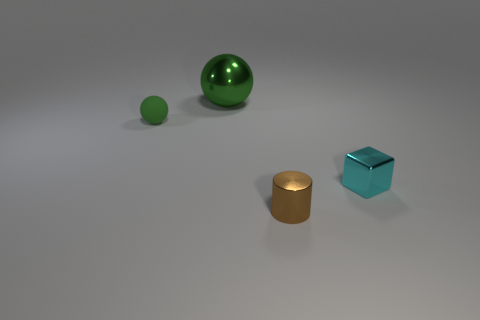Add 3 large yellow metal cylinders. How many objects exist? 7 Subtract all cylinders. How many objects are left? 3 Add 2 green shiny things. How many green shiny things exist? 3 Subtract 0 cyan balls. How many objects are left? 4 Subtract 1 blocks. How many blocks are left? 0 Subtract all gray spheres. Subtract all cyan cubes. How many spheres are left? 2 Subtract all small brown metallic objects. Subtract all blue metal balls. How many objects are left? 3 Add 1 cyan blocks. How many cyan blocks are left? 2 